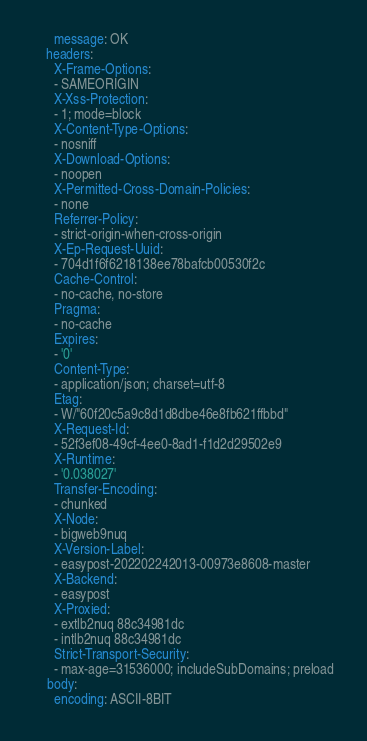<code> <loc_0><loc_0><loc_500><loc_500><_YAML_>      message: OK
    headers:
      X-Frame-Options:
      - SAMEORIGIN
      X-Xss-Protection:
      - 1; mode=block
      X-Content-Type-Options:
      - nosniff
      X-Download-Options:
      - noopen
      X-Permitted-Cross-Domain-Policies:
      - none
      Referrer-Policy:
      - strict-origin-when-cross-origin
      X-Ep-Request-Uuid:
      - 704d1f6f6218138ee78bafcb00530f2c
      Cache-Control:
      - no-cache, no-store
      Pragma:
      - no-cache
      Expires:
      - '0'
      Content-Type:
      - application/json; charset=utf-8
      Etag:
      - W/"60f20c5a9c8d1d8dbe46e8fb621ffbbd"
      X-Request-Id:
      - 52f3ef08-49cf-4ee0-8ad1-f1d2d29502e9
      X-Runtime:
      - '0.038027'
      Transfer-Encoding:
      - chunked
      X-Node:
      - bigweb9nuq
      X-Version-Label:
      - easypost-202202242013-00973e8608-master
      X-Backend:
      - easypost
      X-Proxied:
      - extlb2nuq 88c34981dc
      - intlb2nuq 88c34981dc
      Strict-Transport-Security:
      - max-age=31536000; includeSubDomains; preload
    body:
      encoding: ASCII-8BIT</code> 